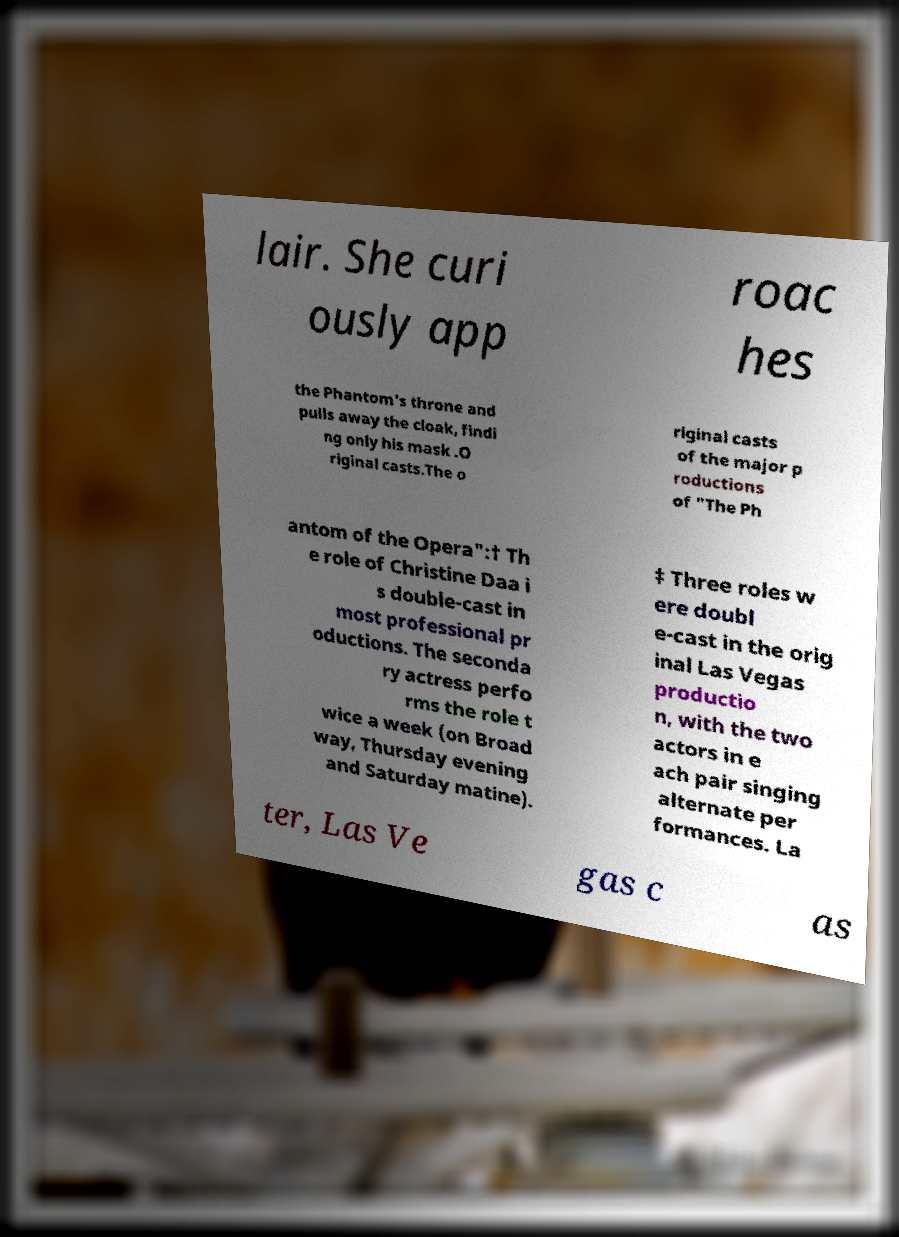Could you extract and type out the text from this image? lair. She curi ously app roac hes the Phantom's throne and pulls away the cloak, findi ng only his mask .O riginal casts.The o riginal casts of the major p roductions of "The Ph antom of the Opera":† Th e role of Christine Daa i s double-cast in most professional pr oductions. The seconda ry actress perfo rms the role t wice a week (on Broad way, Thursday evening and Saturday matine). ‡ Three roles w ere doubl e-cast in the orig inal Las Vegas productio n, with the two actors in e ach pair singing alternate per formances. La ter, Las Ve gas c as 